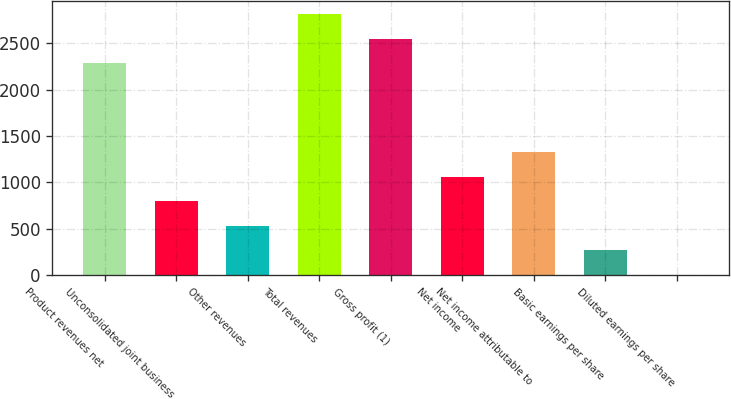<chart> <loc_0><loc_0><loc_500><loc_500><bar_chart><fcel>Product revenues net<fcel>Unconsolidated joint business<fcel>Other revenues<fcel>Total revenues<fcel>Gross profit (1)<fcel>Net income<fcel>Net income attributable to<fcel>Basic earnings per share<fcel>Diluted earnings per share<nl><fcel>2287<fcel>794.84<fcel>531.14<fcel>2814.4<fcel>2550.7<fcel>1058.54<fcel>1322.24<fcel>267.44<fcel>3.74<nl></chart> 